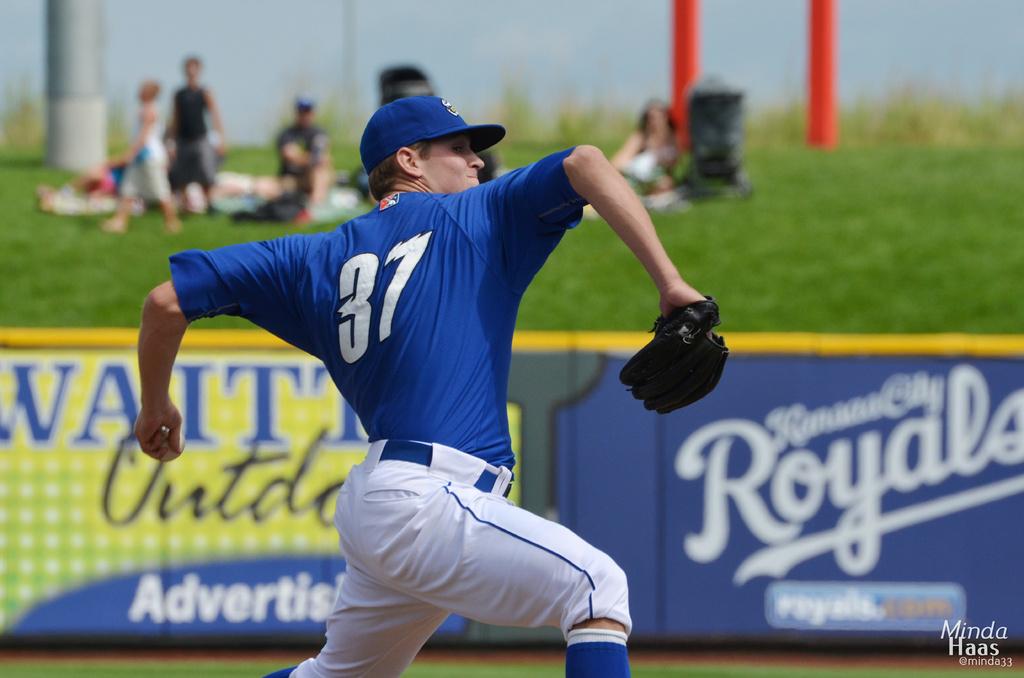Is minda haas the words in the lower right?
Your answer should be very brief. Yes. 